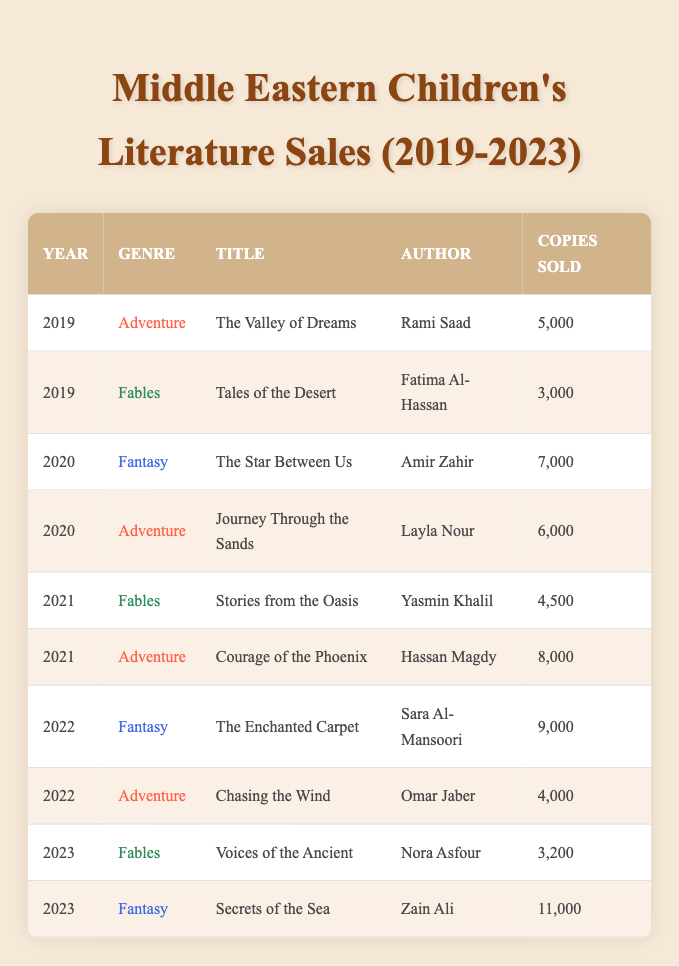What is the best-selling book in the table? To find the best-selling book, I look for the maximum value in the "Copies Sold" column. The highest number is 11,000 copies sold by "Secrets of the Sea" by Zain Ali in 2023.
Answer: Secrets of the Sea Which genre sold the most copies in 2022? In 2022, the "Fantasy" genre had the highest sales, with "The Enchanted Carpet" selling 9,000 copies while "Chasing the Wind" in the "Adventure" genre sold 4,000 copies.
Answer: Fantasy How many copies were sold in total for the "Adventure" genre from 2019 to 2023? I sum the copies sold for all "Adventure" books: 5,000 (2019) + 6,000 (2020) + 8,000 (2021) + 4,000 (2022) = 23,000.
Answer: 23,000 Did any "Fables" book sell more copies than any "Adventure" book in the same year? I check the sales of "Fables" and "Adventure" books by year. In 2021, "Courage of the Phoenix" (Adventure) sold 8,000 copies, more than "Stories from the Oasis" (Fables) which sold 4,500. Similarly, in 2023, "Secrets of the Sea" (Fantasy) sold the highest. Therefore, the answer is no.
Answer: No What was the average number of copies sold for "Fantasy" books from 2019 to 2023? I identify the "Fantasy" books: "The Star Between Us" (7,000), "The Enchanted Carpet" (9,000), and "Secrets of the Sea" (11,000). The total is 7,000 + 9,000 + 11,000 = 27,000, and there are 3 books, so the average is 27,000 / 3 = 9,000.
Answer: 9,000 How many "Fables" books were published in 2023? There is one "Fables" book published in 2023, named "Voices of the Ancient" by Nora Asfour, which sold 3,200 copies.
Answer: 1 Which year had the highest total book sales overall? I sum the total sales for each year: 2019 (8,000), 2020 (13,000), 2021 (12,500), 2022 (13,000), and 2023 (14,200). The highest total is for 2023.
Answer: 2023 Was "Journey Through the Sands" the only "Adventure" book published in 2020? In reviewing the 2020 data, I see two "Adventure" books: "Journey Through the Sands" (6,000) and "The Star Between Us" (Fantasy). Hence, it is not the only one.
Answer: No What is the total sales difference between top-selling "Fantasy" and top-selling "Fables"? The best-selling "Fantasy" is "Secrets of the Sea" (11,000 copies) and the best-selling "Fables" is "Stories from the Oasis" (4,500 copies). The difference is 11,000 - 4,500 = 6,500.
Answer: 6,500 